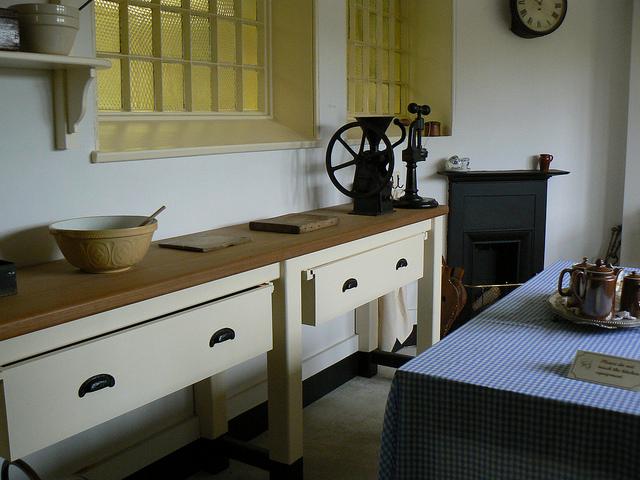Is this a modern kitchen?
Answer briefly. No. What design has the table cover?
Be succinct. Checkered. Is there a fireplace?
Be succinct. Yes. 